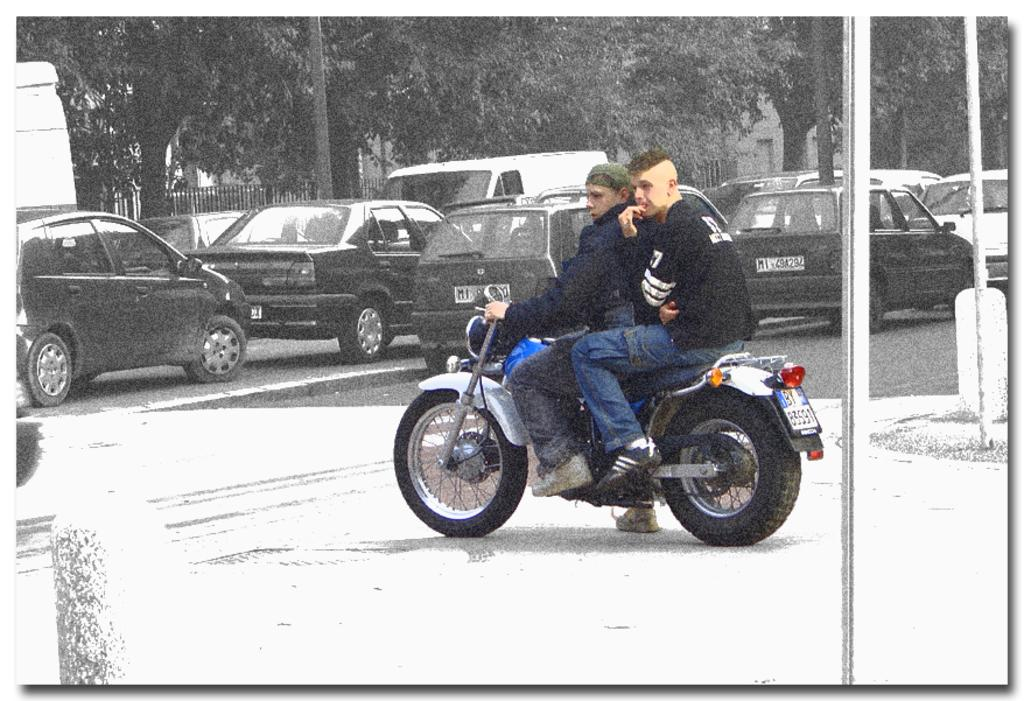What is the main feature of the image? There is a road in the image. What is happening on the road? There are vehicles moving on the road. Can you describe one of the vehicles? There is a motorcycle in the image. How many people are riding the motorcycle? Two persons are riding the motorcycle. What else can be seen in the image besides the road and vehicles? There are trees and buildings visible in the image. What type of spring can be seen on the motorcycle in the image? There is no spring visible on the motorcycle in the image. Can you tell me how fast the persons riding the motorcycle are running in the image? The persons riding the motorcycle are not running; they are riding the motorcycle. 